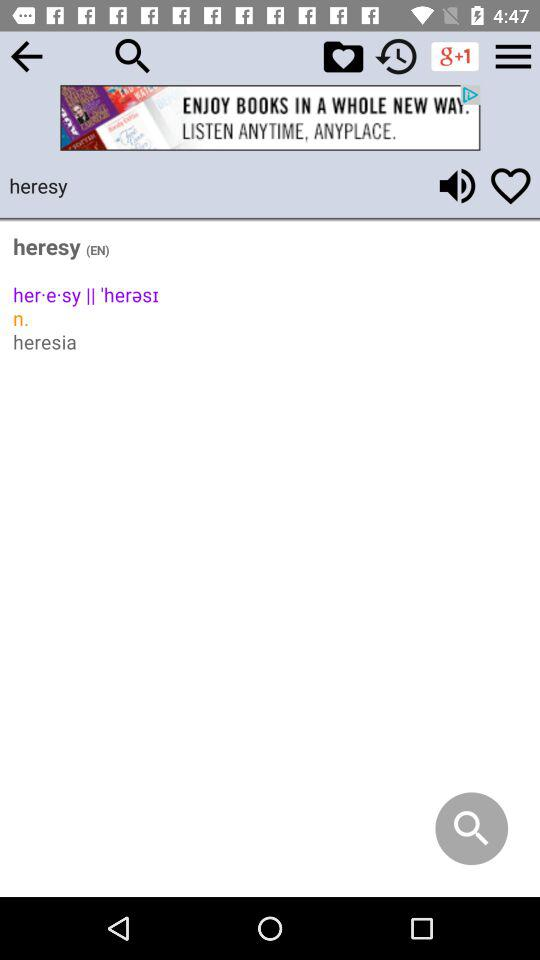What is the word? The word is "heresy". 